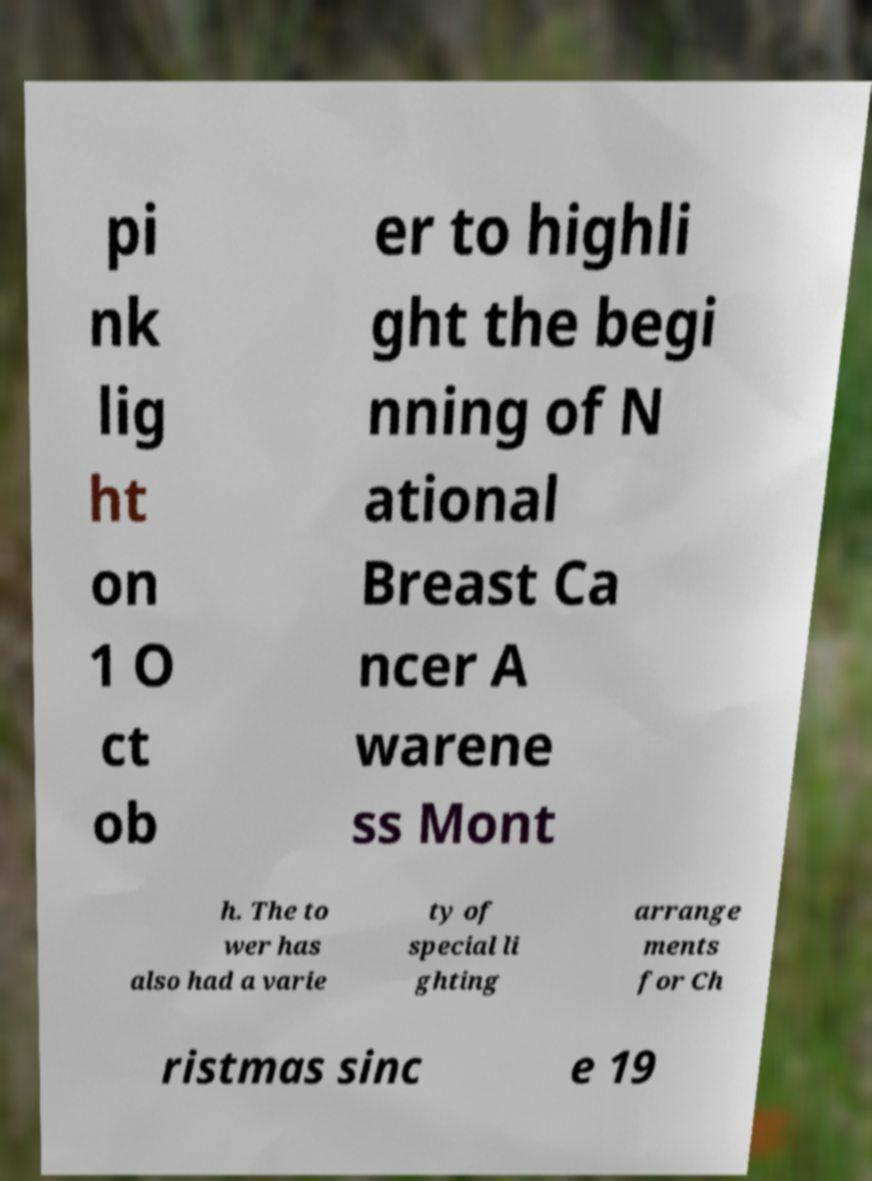Please identify and transcribe the text found in this image. pi nk lig ht on 1 O ct ob er to highli ght the begi nning of N ational Breast Ca ncer A warene ss Mont h. The to wer has also had a varie ty of special li ghting arrange ments for Ch ristmas sinc e 19 